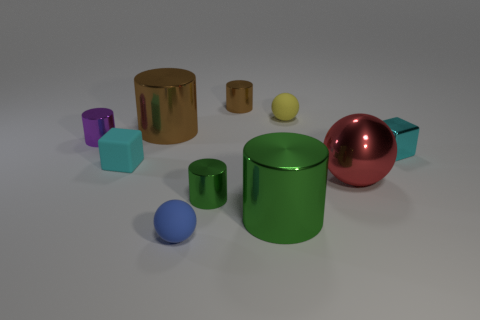Is the number of small cyan matte blocks right of the yellow rubber object greater than the number of tiny purple shiny objects left of the purple cylinder?
Your response must be concise. No. There is a small metallic object that is in front of the tiny yellow thing and behind the cyan shiny cube; what shape is it?
Provide a succinct answer. Cylinder. What is the shape of the brown metallic object that is in front of the tiny brown cylinder?
Keep it short and to the point. Cylinder. There is a metal object that is behind the rubber sphere behind the tiny ball in front of the tiny cyan metallic cube; what is its size?
Keep it short and to the point. Small. Does the small blue thing have the same shape as the red thing?
Ensure brevity in your answer.  Yes. There is a metallic object that is to the right of the large green metal cylinder and behind the tiny matte cube; how big is it?
Provide a succinct answer. Small. There is a small green thing that is the same shape as the purple thing; what material is it?
Your answer should be very brief. Metal. What material is the big object behind the cyan thing that is to the left of the tiny green metal object?
Your answer should be compact. Metal. Do the tiny brown shiny thing and the rubber thing behind the small cyan rubber cube have the same shape?
Offer a very short reply. No. How many rubber things are either tiny cyan cubes or small green things?
Your response must be concise. 1. 